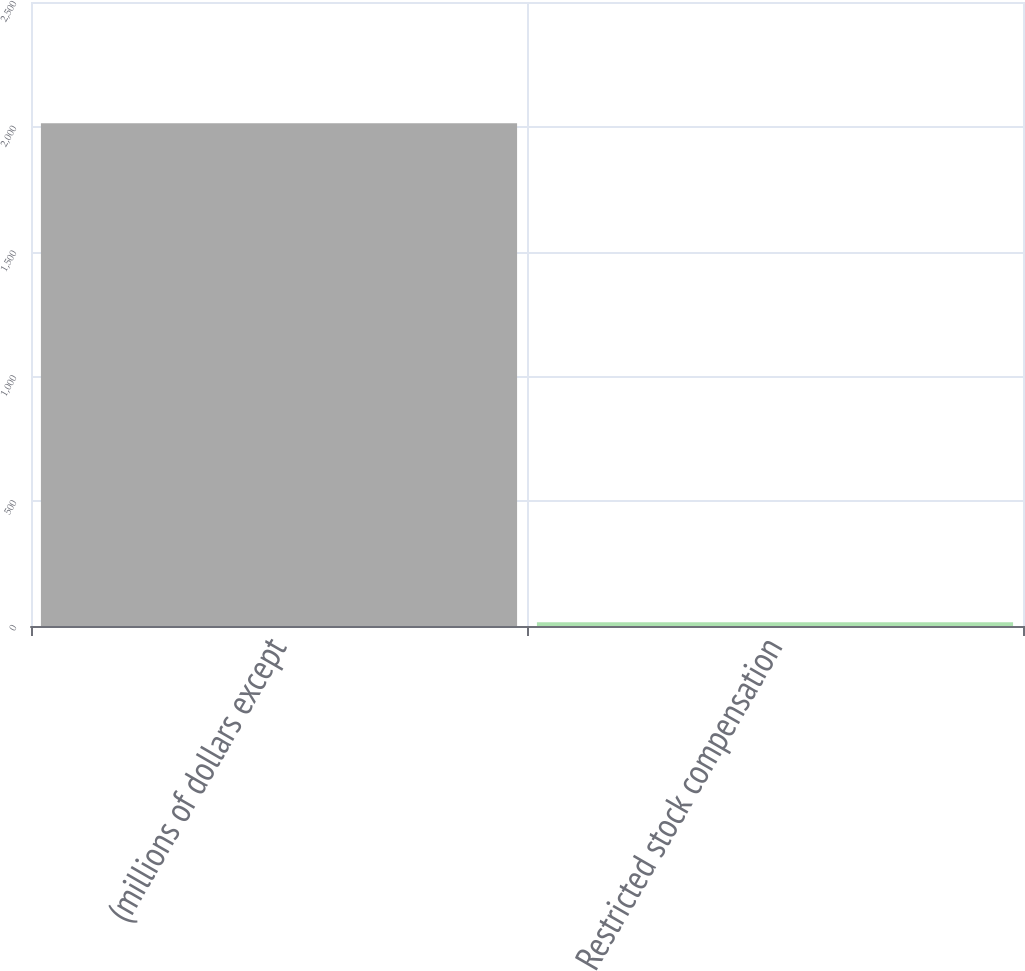Convert chart. <chart><loc_0><loc_0><loc_500><loc_500><bar_chart><fcel>(millions of dollars except<fcel>Restricted stock compensation<nl><fcel>2014<fcel>15.1<nl></chart> 